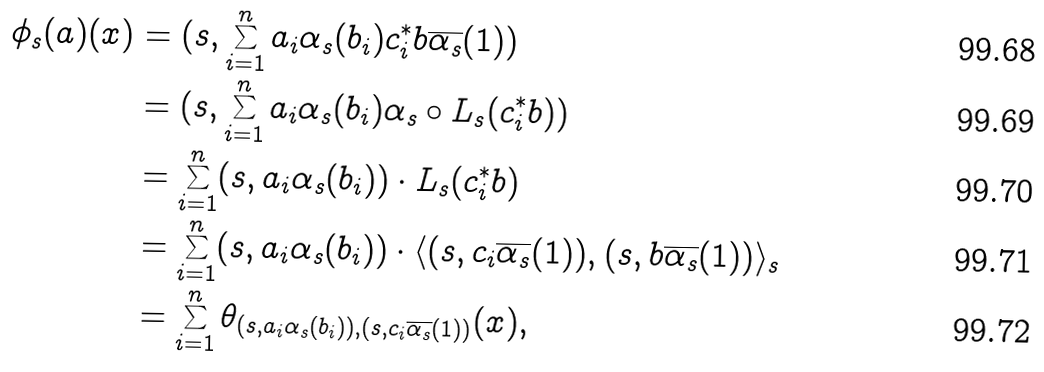<formula> <loc_0><loc_0><loc_500><loc_500>\phi _ { s } ( a ) ( x ) & = ( s , \sum _ { i = 1 } ^ { n } a _ { i } \alpha _ { s } ( b _ { i } ) c _ { i } ^ { * } b \overline { \alpha _ { s } } ( 1 ) ) \\ & = ( s , \sum _ { i = 1 } ^ { n } a _ { i } \alpha _ { s } ( b _ { i } ) \alpha _ { s } \circ L _ { s } ( c _ { i } ^ { * } b ) ) \\ & = \sum _ { i = 1 } ^ { n } ( s , a _ { i } \alpha _ { s } ( b _ { i } ) ) \cdot L _ { s } ( c _ { i } ^ { * } b ) \\ & = \sum _ { i = 1 } ^ { n } ( s , a _ { i } \alpha _ { s } ( b _ { i } ) ) \cdot \langle ( s , c _ { i } \overline { \alpha _ { s } } ( 1 ) ) , ( s , b \overline { \alpha _ { s } } ( 1 ) ) \rangle _ { s } \\ & = \sum _ { i = 1 } ^ { n } \theta _ { ( s , a _ { i } \alpha _ { s } ( b _ { i } ) ) , ( s , c _ { i } \overline { \alpha _ { s } } ( 1 ) ) } ( x ) ,</formula> 